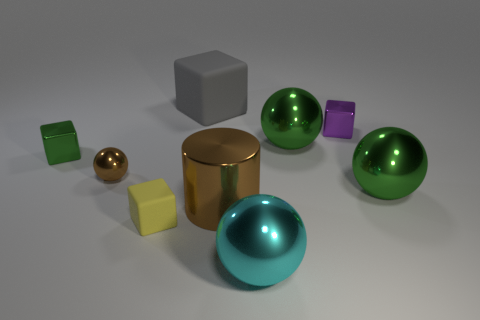Subtract all balls. How many objects are left? 5 Subtract 1 cylinders. How many cylinders are left? 0 Subtract all brown blocks. Subtract all purple cylinders. How many blocks are left? 4 Subtract all gray blocks. How many cyan spheres are left? 1 Subtract all shiny objects. Subtract all small brown shiny balls. How many objects are left? 1 Add 9 tiny purple blocks. How many tiny purple blocks are left? 10 Add 2 large gray spheres. How many large gray spheres exist? 2 Add 1 small blue balls. How many objects exist? 10 Subtract all brown spheres. How many spheres are left? 3 Subtract all big gray rubber blocks. How many blocks are left? 3 